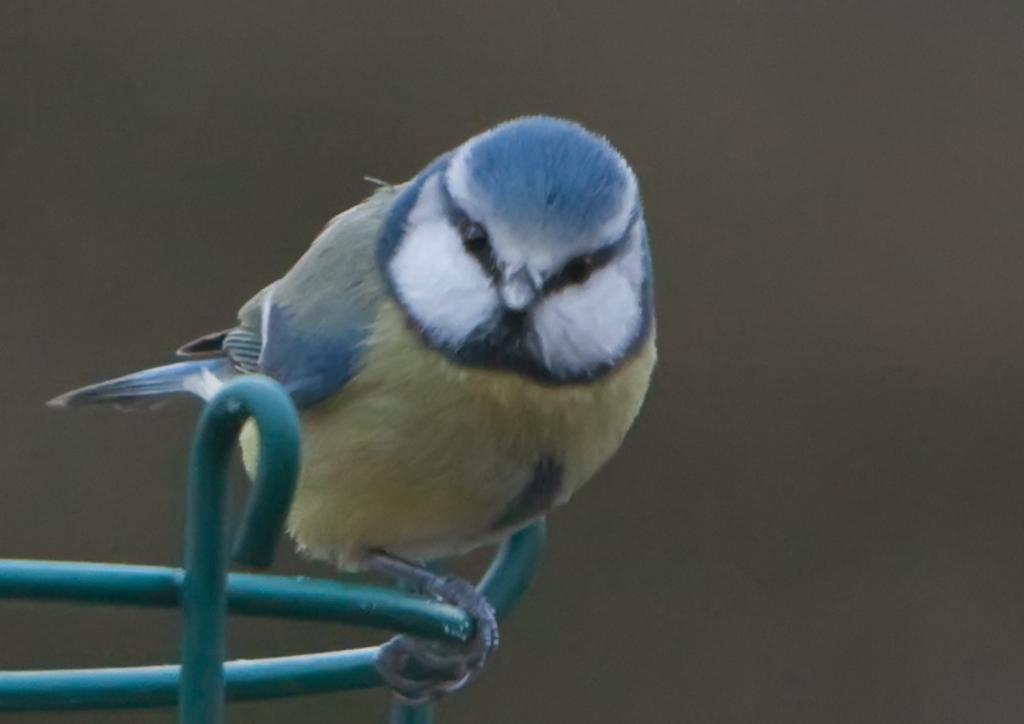Describe this image in one or two sentences. In this image there is a bird. 